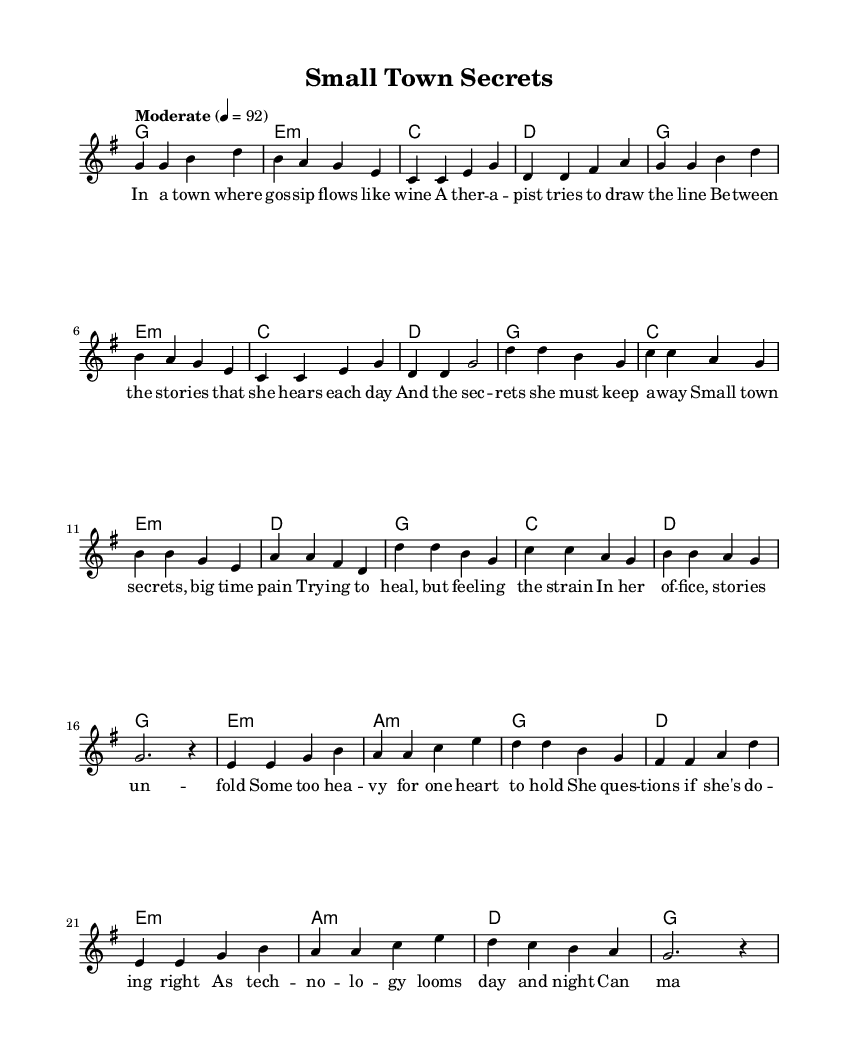What is the key signature of this music? The key signature is G major, which has one sharp (F#). This can be identified by looking at the key signature notation at the beginning of the staff.
Answer: G major What is the time signature of this music? The time signature is 4/4, indicated at the beginning of the score. This means there are four beats in a measure and the quarter note gets one beat.
Answer: 4/4 What is the tempo marking for this piece? The tempo marking is "Moderate" with a metronome indication of 4 = 92, which shows the piece should be played at a moderate speed. This is noted under the tempo indication in the score.
Answer: Moderate How many verses are in the lyrics? There are two verses in the lyrics, as we can identify distinct sections labeled 'verseWords' and 'chorusWords' which indicate the structure.
Answer: Two What is the main theme of the song's lyrics? The main theme is about the struggles of a small-town therapist as she navigates her patients' secrets and the ethical implications of therapy, connecting to a broader commentary on mental health. This can be inferred from the lyrics' focus on "small town secrets" and the therapist's challenges.
Answer: Struggles of a therapist What harmonic progression is used in the chorus? The harmonic progression in the chorus follows a pattern starting with G major, moving to E minor, C major, and then D major. This can be analyzed by looking at the chord changes written alongside the lyrics.
Answer: G, E:min, C, D What reflective question does the bridge raise about technology? The bridge raises the question of whether machines can replace human care in therapy, highlighting skepticism about AI in mental health treatment. This is derived from the lyrics that directly question the effectiveness and ethical implications of technological interventions.
Answer: Can machines replace human care? 